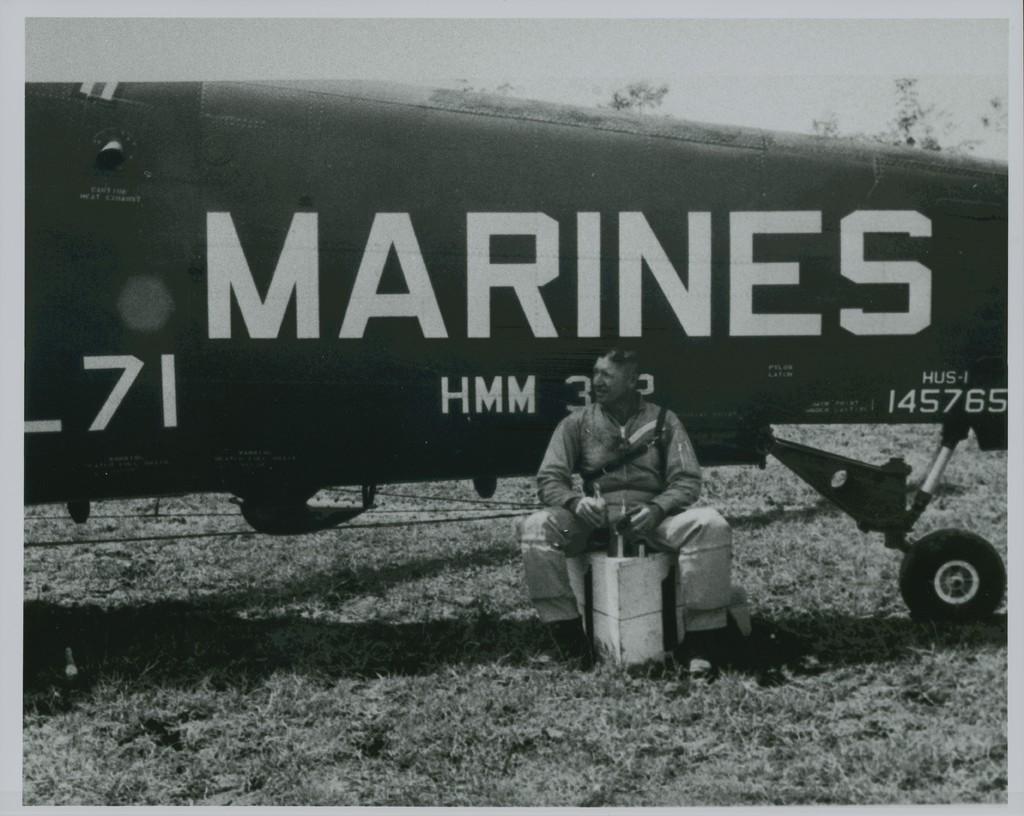What branch of the military is in this photo?
Offer a very short reply. Marines. What letters are on the plan next to the sitting man?
Provide a short and direct response. Hmm. 